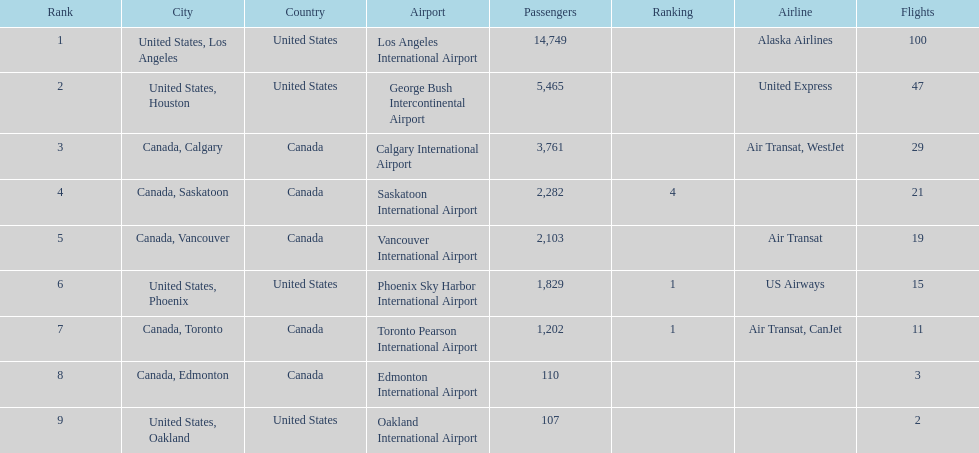Could you parse the entire table as a dict? {'header': ['Rank', 'City', 'Country', 'Airport', 'Passengers', 'Ranking', 'Airline', 'Flights'], 'rows': [['1', 'United States, Los Angeles', 'United States', 'Los Angeles International Airport', '14,749', '', 'Alaska Airlines', '100'], ['2', 'United States, Houston', 'United States', 'George Bush Intercontinental Airport', '5,465', '', 'United Express', '47'], ['3', 'Canada, Calgary', 'Canada', 'Calgary International Airport', '3,761', '', 'Air Transat, WestJet', '29'], ['4', 'Canada, Saskatoon', 'Canada', 'Saskatoon International Airport', '2,282', '4', '', '21'], ['5', 'Canada, Vancouver', 'Canada', 'Vancouver International Airport', '2,103', '', 'Air Transat', '19'], ['6', 'United States, Phoenix', 'United States', 'Phoenix Sky Harbor International Airport', '1,829', '1', 'US Airways', '15'], ['7', 'Canada, Toronto', 'Canada', 'Toronto Pearson International Airport', '1,202', '1', 'Air Transat, CanJet', '11'], ['8', 'Canada, Edmonton', 'Canada', 'Edmonton International Airport', '110', '', '', '3'], ['9', 'United States, Oakland', 'United States', 'Oakland International Airport', '107', '', '', '2']]} Which canadian city had the most passengers traveling from manzanillo international airport in 2013? Calgary. 